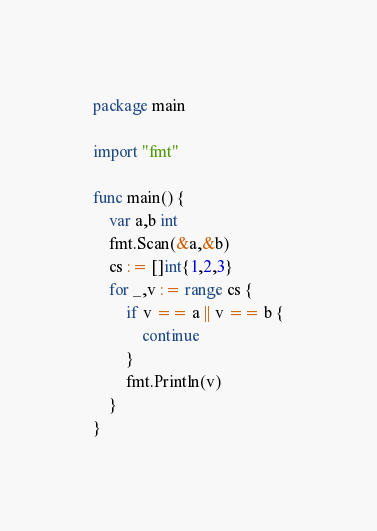Convert code to text. <code><loc_0><loc_0><loc_500><loc_500><_Go_>package main

import "fmt"

func main() {
	var a,b int
	fmt.Scan(&a,&b)
	cs := []int{1,2,3}
	for _,v := range cs {
		if v == a || v == b {
			continue
		}
		fmt.Println(v)
	}
}
</code> 